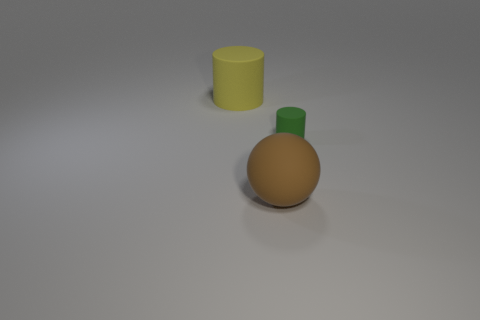Add 3 tiny green rubber cylinders. How many objects exist? 6 Subtract all cylinders. How many objects are left? 1 Add 3 yellow things. How many yellow things are left? 4 Add 3 brown spheres. How many brown spheres exist? 4 Subtract 0 red cylinders. How many objects are left? 3 Subtract all cyan metal balls. Subtract all brown objects. How many objects are left? 2 